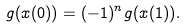<formula> <loc_0><loc_0><loc_500><loc_500>g ( x ( 0 ) ) = ( - 1 ) ^ { n } g ( x ( 1 ) ) .</formula> 